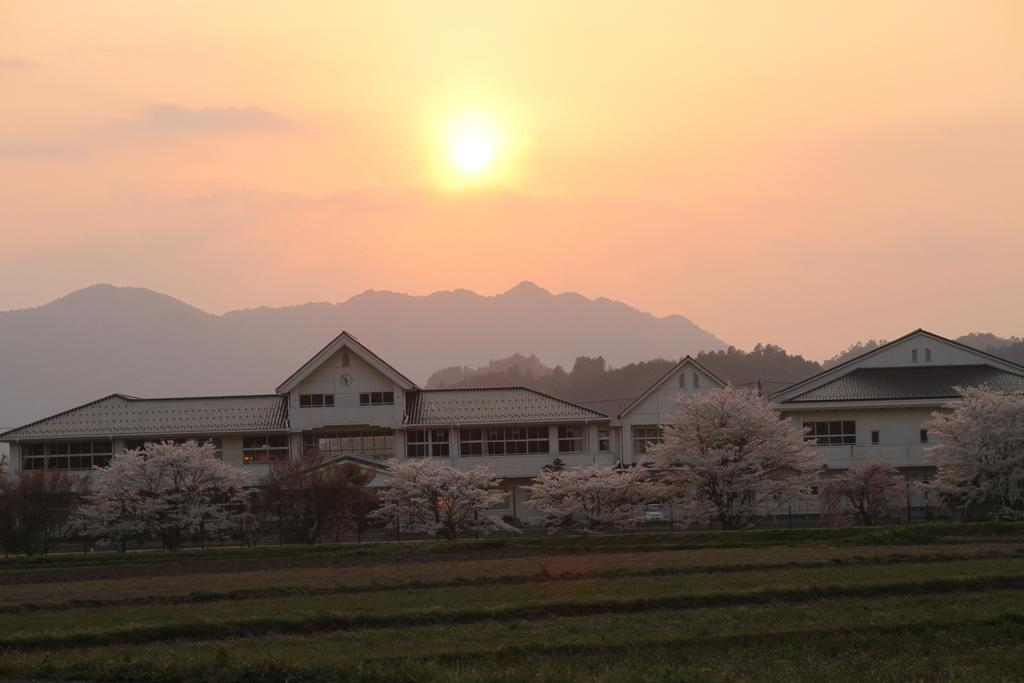What type of structures can be seen in the image? There are houses in the image. What type of vegetation is present in the image? There are trees and grass in the image. What can be seen in the background of the image? There are mountains, sky, and the sun visible in the background of the image. What type of mint is growing in the image? There is no mint present in the image. How does the plough help in the cultivation of the grass in the image? There is no plough present in the image, and the grass is not being cultivated. 